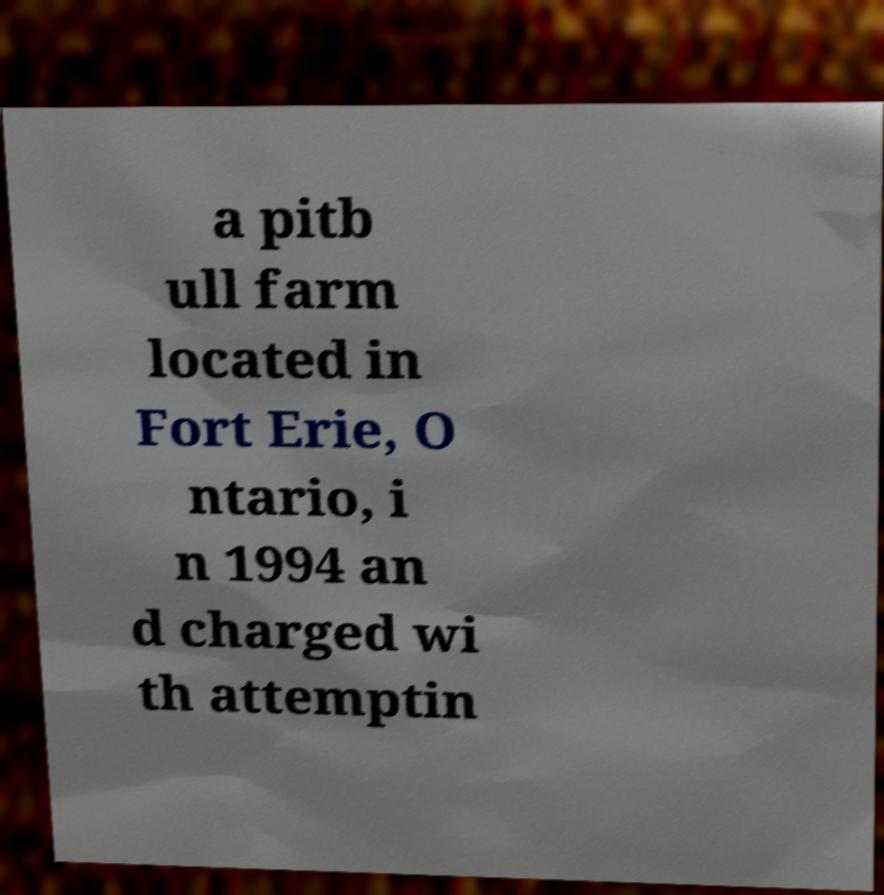Please identify and transcribe the text found in this image. a pitb ull farm located in Fort Erie, O ntario, i n 1994 an d charged wi th attemptin 